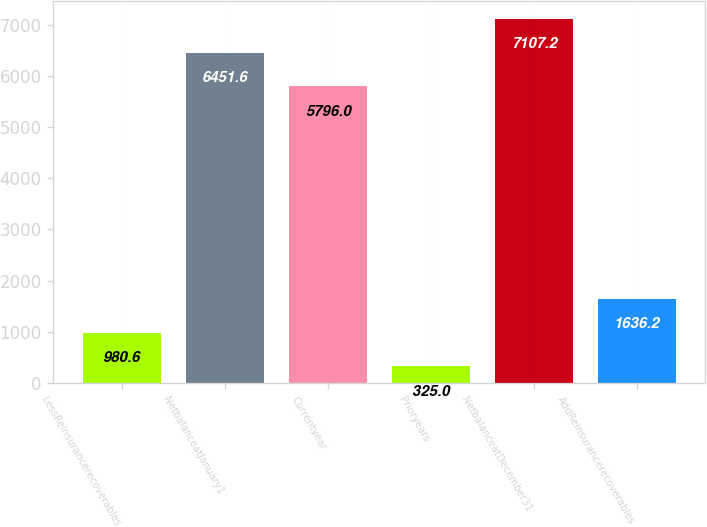<chart> <loc_0><loc_0><loc_500><loc_500><bar_chart><fcel>LessReinsurancerecoverables<fcel>NetbalanceatJanuary1<fcel>Currentyear<fcel>Prioryears<fcel>NetbalanceatDecember31<fcel>AddReinsurancerecoverables<nl><fcel>980.6<fcel>6451.6<fcel>5796<fcel>325<fcel>7107.2<fcel>1636.2<nl></chart> 